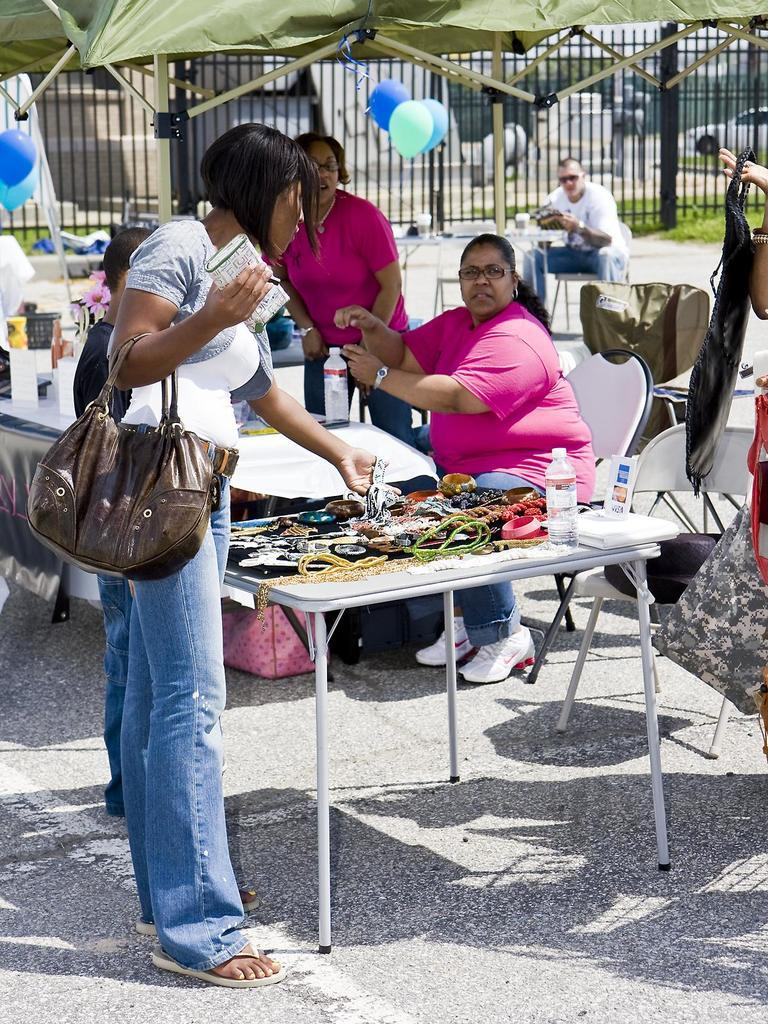How many people are in the image? There are people in the image, but the exact number is not specified. What are some of the people doing in the image? Some people are sitting, and some people are standing in the image. What decorative items can be seen in the image? There are balloons in the image. What type of shelter is present in the image? There is a tent in the image. What type of spade is being used to start the fire in the image? There is no spade or fire present in the image. What is the reason for the people gathering in the image? The reason for the people gathering in the image is not specified in the facts provided. 